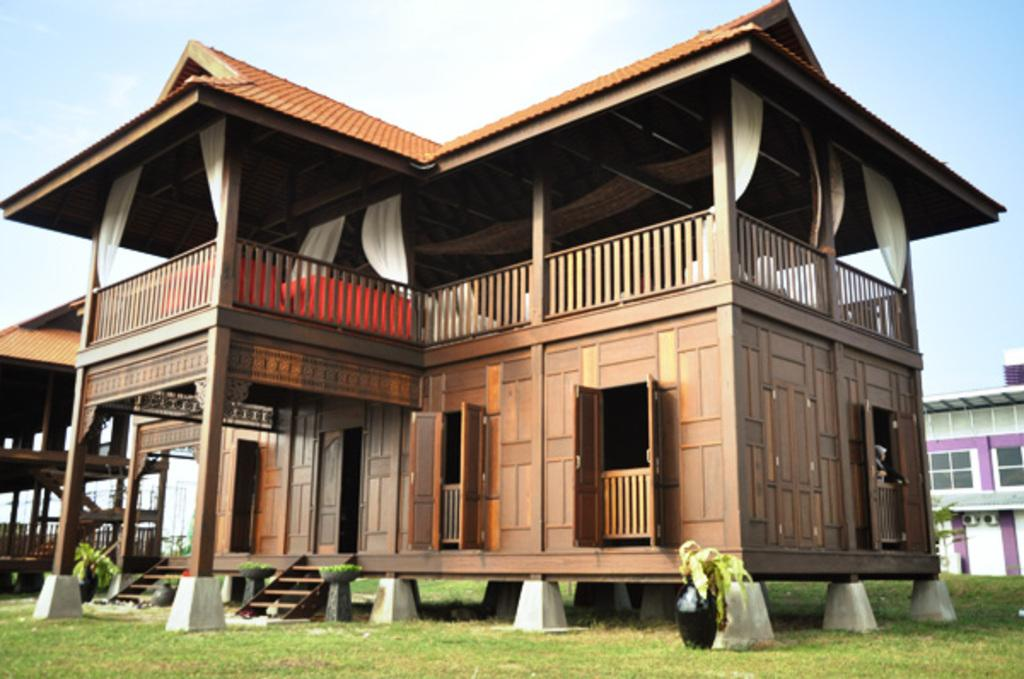What type of structures can be seen in the image? There are buildings in the image. What type of window treatment is present in the image? There are white color curtains in the image. What type of vegetation is visible in the image? There are plants and grass visible in the image. What is visible in the background of the image? The sky is visible in the background of the image. How many chickens are visible in the image? There are no chickens present in the image. What is the image of the buildings being pushed by in the image? The image does not depict any pushing or movement of the buildings. 